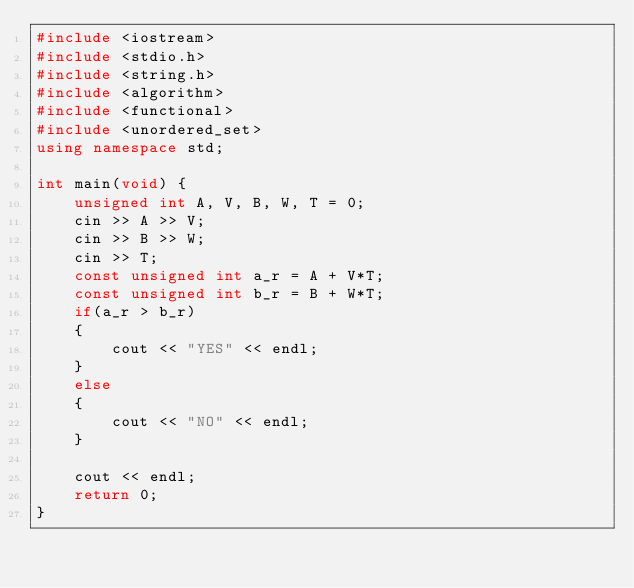Convert code to text. <code><loc_0><loc_0><loc_500><loc_500><_C++_>#include <iostream>
#include <stdio.h>
#include <string.h>
#include <algorithm>
#include <functional>
#include <unordered_set>
using namespace std;

int main(void) {
    unsigned int A, V, B, W, T = 0;
    cin >> A >> V;
    cin >> B >> W;
    cin >> T;
    const unsigned int a_r = A + V*T;
    const unsigned int b_r = B + W*T;
    if(a_r > b_r)
    {
        cout << "YES" << endl;
    }
    else
    {
        cout << "NO" << endl;
    }
    
    cout << endl;
    return 0;
}

</code> 